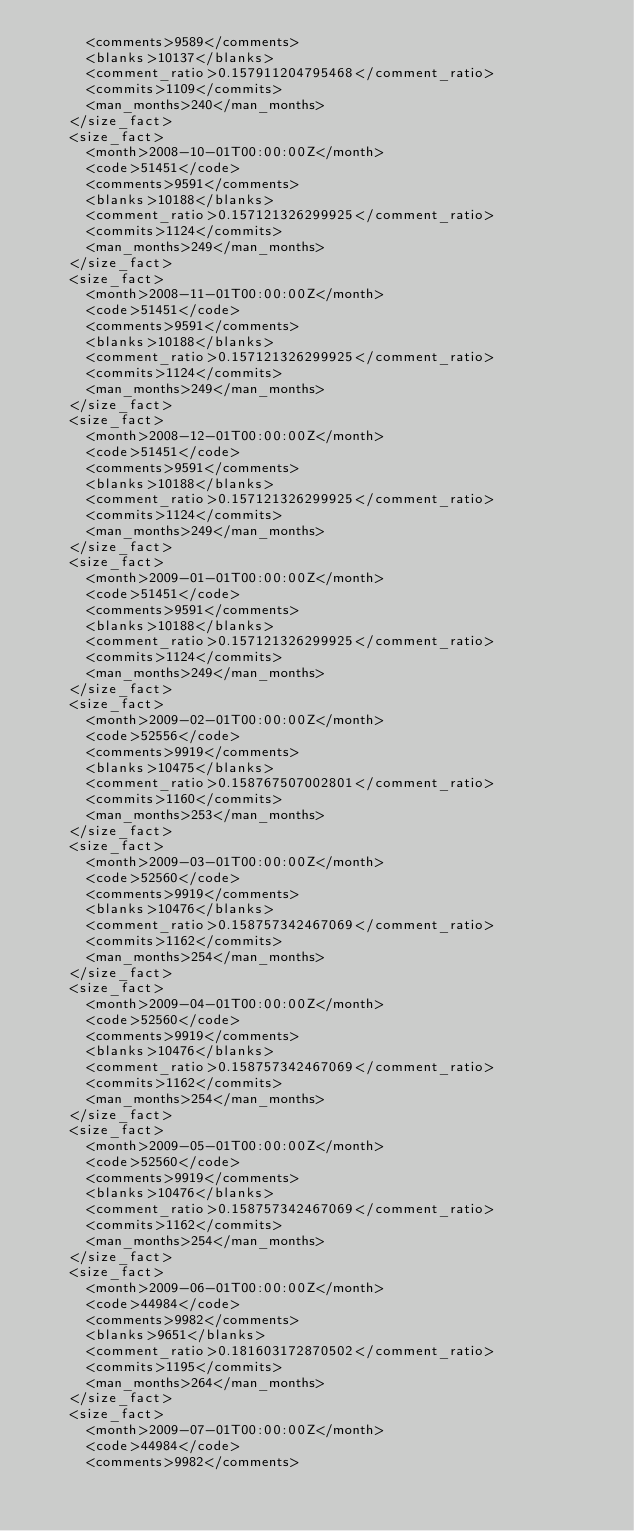<code> <loc_0><loc_0><loc_500><loc_500><_XML_>      <comments>9589</comments>
      <blanks>10137</blanks>
      <comment_ratio>0.157911204795468</comment_ratio>
      <commits>1109</commits>
      <man_months>240</man_months>
    </size_fact>
    <size_fact>
      <month>2008-10-01T00:00:00Z</month>
      <code>51451</code>
      <comments>9591</comments>
      <blanks>10188</blanks>
      <comment_ratio>0.157121326299925</comment_ratio>
      <commits>1124</commits>
      <man_months>249</man_months>
    </size_fact>
    <size_fact>
      <month>2008-11-01T00:00:00Z</month>
      <code>51451</code>
      <comments>9591</comments>
      <blanks>10188</blanks>
      <comment_ratio>0.157121326299925</comment_ratio>
      <commits>1124</commits>
      <man_months>249</man_months>
    </size_fact>
    <size_fact>
      <month>2008-12-01T00:00:00Z</month>
      <code>51451</code>
      <comments>9591</comments>
      <blanks>10188</blanks>
      <comment_ratio>0.157121326299925</comment_ratio>
      <commits>1124</commits>
      <man_months>249</man_months>
    </size_fact>
    <size_fact>
      <month>2009-01-01T00:00:00Z</month>
      <code>51451</code>
      <comments>9591</comments>
      <blanks>10188</blanks>
      <comment_ratio>0.157121326299925</comment_ratio>
      <commits>1124</commits>
      <man_months>249</man_months>
    </size_fact>
    <size_fact>
      <month>2009-02-01T00:00:00Z</month>
      <code>52556</code>
      <comments>9919</comments>
      <blanks>10475</blanks>
      <comment_ratio>0.158767507002801</comment_ratio>
      <commits>1160</commits>
      <man_months>253</man_months>
    </size_fact>
    <size_fact>
      <month>2009-03-01T00:00:00Z</month>
      <code>52560</code>
      <comments>9919</comments>
      <blanks>10476</blanks>
      <comment_ratio>0.158757342467069</comment_ratio>
      <commits>1162</commits>
      <man_months>254</man_months>
    </size_fact>
    <size_fact>
      <month>2009-04-01T00:00:00Z</month>
      <code>52560</code>
      <comments>9919</comments>
      <blanks>10476</blanks>
      <comment_ratio>0.158757342467069</comment_ratio>
      <commits>1162</commits>
      <man_months>254</man_months>
    </size_fact>
    <size_fact>
      <month>2009-05-01T00:00:00Z</month>
      <code>52560</code>
      <comments>9919</comments>
      <blanks>10476</blanks>
      <comment_ratio>0.158757342467069</comment_ratio>
      <commits>1162</commits>
      <man_months>254</man_months>
    </size_fact>
    <size_fact>
      <month>2009-06-01T00:00:00Z</month>
      <code>44984</code>
      <comments>9982</comments>
      <blanks>9651</blanks>
      <comment_ratio>0.181603172870502</comment_ratio>
      <commits>1195</commits>
      <man_months>264</man_months>
    </size_fact>
    <size_fact>
      <month>2009-07-01T00:00:00Z</month>
      <code>44984</code>
      <comments>9982</comments></code> 